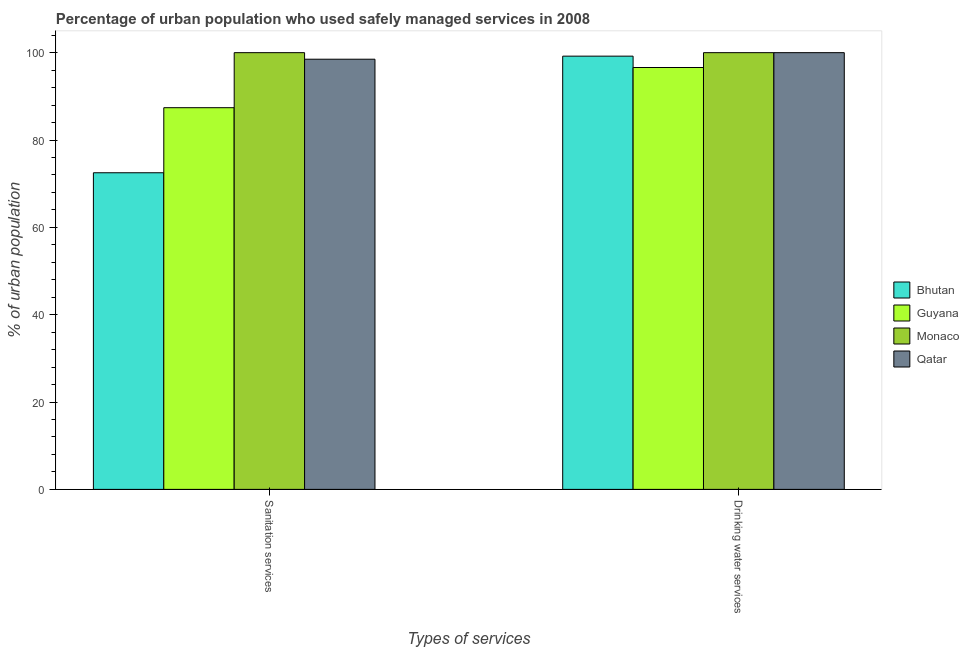How many different coloured bars are there?
Your answer should be compact. 4. How many groups of bars are there?
Your answer should be very brief. 2. Are the number of bars per tick equal to the number of legend labels?
Give a very brief answer. Yes. Are the number of bars on each tick of the X-axis equal?
Your response must be concise. Yes. How many bars are there on the 1st tick from the left?
Give a very brief answer. 4. What is the label of the 2nd group of bars from the left?
Keep it short and to the point. Drinking water services. What is the percentage of urban population who used drinking water services in Monaco?
Provide a short and direct response. 100. Across all countries, what is the minimum percentage of urban population who used drinking water services?
Your answer should be compact. 96.6. In which country was the percentage of urban population who used drinking water services maximum?
Provide a succinct answer. Monaco. In which country was the percentage of urban population who used sanitation services minimum?
Ensure brevity in your answer.  Bhutan. What is the total percentage of urban population who used drinking water services in the graph?
Your answer should be compact. 395.8. What is the difference between the percentage of urban population who used sanitation services in Guyana and that in Qatar?
Your answer should be very brief. -11.1. What is the difference between the percentage of urban population who used sanitation services in Bhutan and the percentage of urban population who used drinking water services in Guyana?
Your answer should be compact. -24.1. What is the average percentage of urban population who used sanitation services per country?
Offer a terse response. 89.6. What is the ratio of the percentage of urban population who used sanitation services in Monaco to that in Qatar?
Offer a terse response. 1.02. Is the percentage of urban population who used drinking water services in Monaco less than that in Guyana?
Your response must be concise. No. In how many countries, is the percentage of urban population who used sanitation services greater than the average percentage of urban population who used sanitation services taken over all countries?
Your answer should be very brief. 2. What does the 3rd bar from the left in Sanitation services represents?
Your answer should be compact. Monaco. What does the 4th bar from the right in Sanitation services represents?
Ensure brevity in your answer.  Bhutan. How many countries are there in the graph?
Your answer should be compact. 4. What is the difference between two consecutive major ticks on the Y-axis?
Offer a very short reply. 20. Are the values on the major ticks of Y-axis written in scientific E-notation?
Offer a very short reply. No. Does the graph contain grids?
Your answer should be very brief. No. Where does the legend appear in the graph?
Keep it short and to the point. Center right. How are the legend labels stacked?
Your answer should be very brief. Vertical. What is the title of the graph?
Make the answer very short. Percentage of urban population who used safely managed services in 2008. What is the label or title of the X-axis?
Provide a succinct answer. Types of services. What is the label or title of the Y-axis?
Your answer should be compact. % of urban population. What is the % of urban population of Bhutan in Sanitation services?
Keep it short and to the point. 72.5. What is the % of urban population of Guyana in Sanitation services?
Give a very brief answer. 87.4. What is the % of urban population of Monaco in Sanitation services?
Your answer should be compact. 100. What is the % of urban population of Qatar in Sanitation services?
Your answer should be very brief. 98.5. What is the % of urban population in Bhutan in Drinking water services?
Ensure brevity in your answer.  99.2. What is the % of urban population in Guyana in Drinking water services?
Offer a very short reply. 96.6. What is the % of urban population in Monaco in Drinking water services?
Your answer should be very brief. 100. Across all Types of services, what is the maximum % of urban population of Bhutan?
Your answer should be very brief. 99.2. Across all Types of services, what is the maximum % of urban population of Guyana?
Ensure brevity in your answer.  96.6. Across all Types of services, what is the maximum % of urban population in Monaco?
Your answer should be compact. 100. Across all Types of services, what is the maximum % of urban population in Qatar?
Keep it short and to the point. 100. Across all Types of services, what is the minimum % of urban population in Bhutan?
Provide a succinct answer. 72.5. Across all Types of services, what is the minimum % of urban population of Guyana?
Make the answer very short. 87.4. Across all Types of services, what is the minimum % of urban population of Monaco?
Give a very brief answer. 100. Across all Types of services, what is the minimum % of urban population in Qatar?
Your answer should be very brief. 98.5. What is the total % of urban population of Bhutan in the graph?
Your response must be concise. 171.7. What is the total % of urban population in Guyana in the graph?
Your answer should be compact. 184. What is the total % of urban population in Monaco in the graph?
Your answer should be compact. 200. What is the total % of urban population in Qatar in the graph?
Provide a succinct answer. 198.5. What is the difference between the % of urban population in Bhutan in Sanitation services and that in Drinking water services?
Your response must be concise. -26.7. What is the difference between the % of urban population in Bhutan in Sanitation services and the % of urban population in Guyana in Drinking water services?
Offer a very short reply. -24.1. What is the difference between the % of urban population in Bhutan in Sanitation services and the % of urban population in Monaco in Drinking water services?
Provide a succinct answer. -27.5. What is the difference between the % of urban population in Bhutan in Sanitation services and the % of urban population in Qatar in Drinking water services?
Offer a terse response. -27.5. What is the difference between the % of urban population of Guyana in Sanitation services and the % of urban population of Qatar in Drinking water services?
Provide a succinct answer. -12.6. What is the difference between the % of urban population of Monaco in Sanitation services and the % of urban population of Qatar in Drinking water services?
Provide a succinct answer. 0. What is the average % of urban population in Bhutan per Types of services?
Provide a short and direct response. 85.85. What is the average % of urban population of Guyana per Types of services?
Offer a terse response. 92. What is the average % of urban population in Qatar per Types of services?
Ensure brevity in your answer.  99.25. What is the difference between the % of urban population of Bhutan and % of urban population of Guyana in Sanitation services?
Your answer should be compact. -14.9. What is the difference between the % of urban population of Bhutan and % of urban population of Monaco in Sanitation services?
Your answer should be compact. -27.5. What is the difference between the % of urban population of Bhutan and % of urban population of Qatar in Sanitation services?
Ensure brevity in your answer.  -26. What is the difference between the % of urban population of Guyana and % of urban population of Monaco in Sanitation services?
Give a very brief answer. -12.6. What is the difference between the % of urban population of Monaco and % of urban population of Qatar in Sanitation services?
Make the answer very short. 1.5. What is the difference between the % of urban population in Bhutan and % of urban population in Guyana in Drinking water services?
Give a very brief answer. 2.6. What is the difference between the % of urban population in Bhutan and % of urban population in Monaco in Drinking water services?
Provide a short and direct response. -0.8. What is the difference between the % of urban population in Bhutan and % of urban population in Qatar in Drinking water services?
Keep it short and to the point. -0.8. What is the difference between the % of urban population of Guyana and % of urban population of Monaco in Drinking water services?
Provide a short and direct response. -3.4. What is the difference between the % of urban population in Guyana and % of urban population in Qatar in Drinking water services?
Offer a terse response. -3.4. What is the ratio of the % of urban population in Bhutan in Sanitation services to that in Drinking water services?
Provide a short and direct response. 0.73. What is the ratio of the % of urban population of Guyana in Sanitation services to that in Drinking water services?
Provide a short and direct response. 0.9. What is the ratio of the % of urban population of Qatar in Sanitation services to that in Drinking water services?
Give a very brief answer. 0.98. What is the difference between the highest and the second highest % of urban population in Bhutan?
Offer a terse response. 26.7. What is the difference between the highest and the second highest % of urban population of Guyana?
Your answer should be very brief. 9.2. What is the difference between the highest and the second highest % of urban population in Monaco?
Make the answer very short. 0. What is the difference between the highest and the second highest % of urban population of Qatar?
Provide a succinct answer. 1.5. What is the difference between the highest and the lowest % of urban population in Bhutan?
Offer a very short reply. 26.7. What is the difference between the highest and the lowest % of urban population of Guyana?
Ensure brevity in your answer.  9.2. What is the difference between the highest and the lowest % of urban population in Qatar?
Provide a succinct answer. 1.5. 